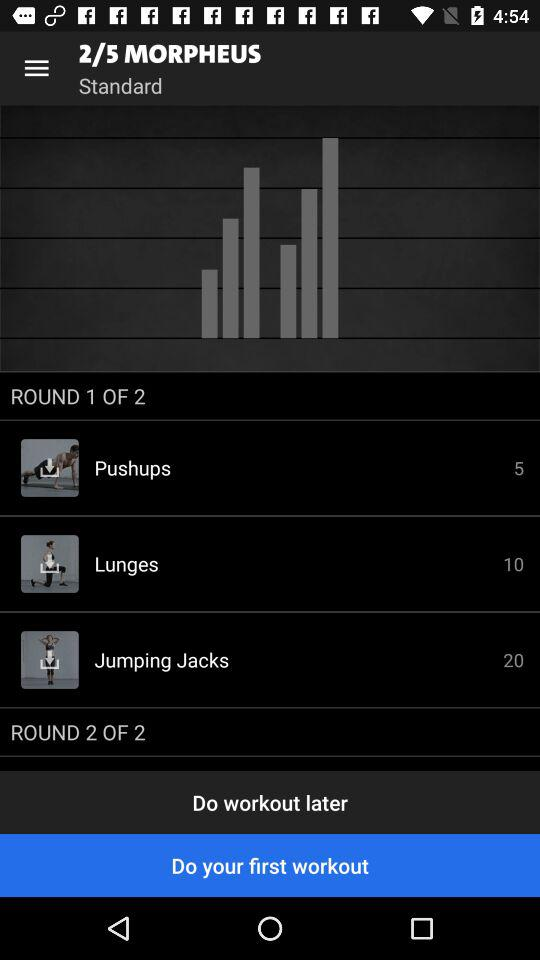Which exercises are in round 1? The exercises in round 1 are pushups, lunges and jumping jacks. 